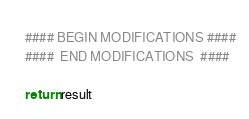Convert code to text. <code><loc_0><loc_0><loc_500><loc_500><_Python_>	
	#### BEGIN MODIFICATIONS ####
	####  END MODIFICATIONS  ####
	
	return result</code> 